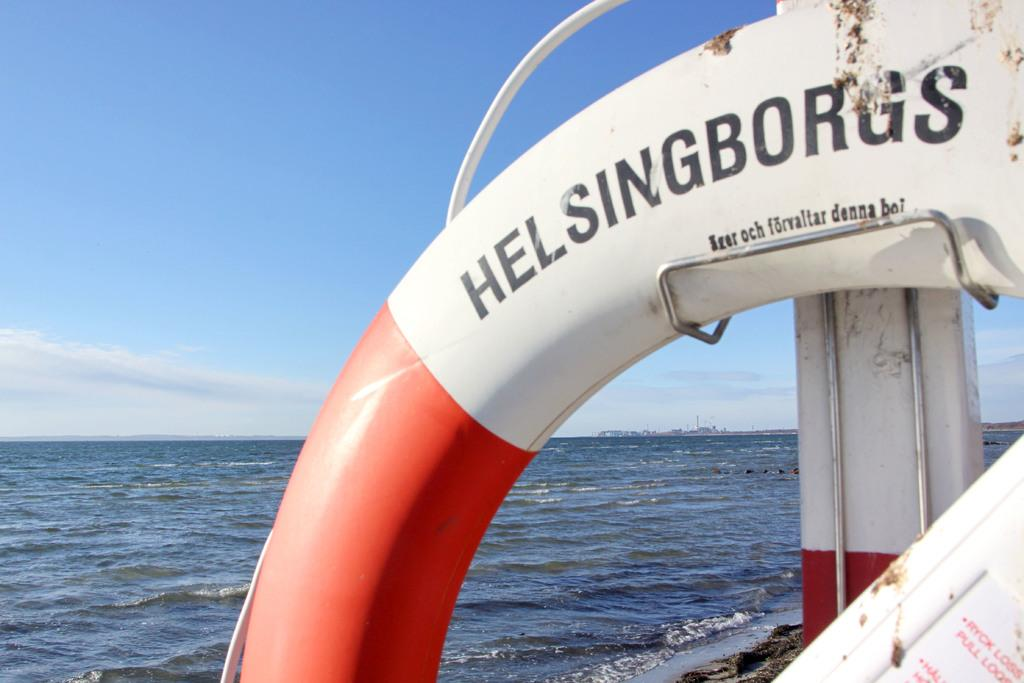<image>
Give a short and clear explanation of the subsequent image. A orange and white life ring by Helsingborgs 